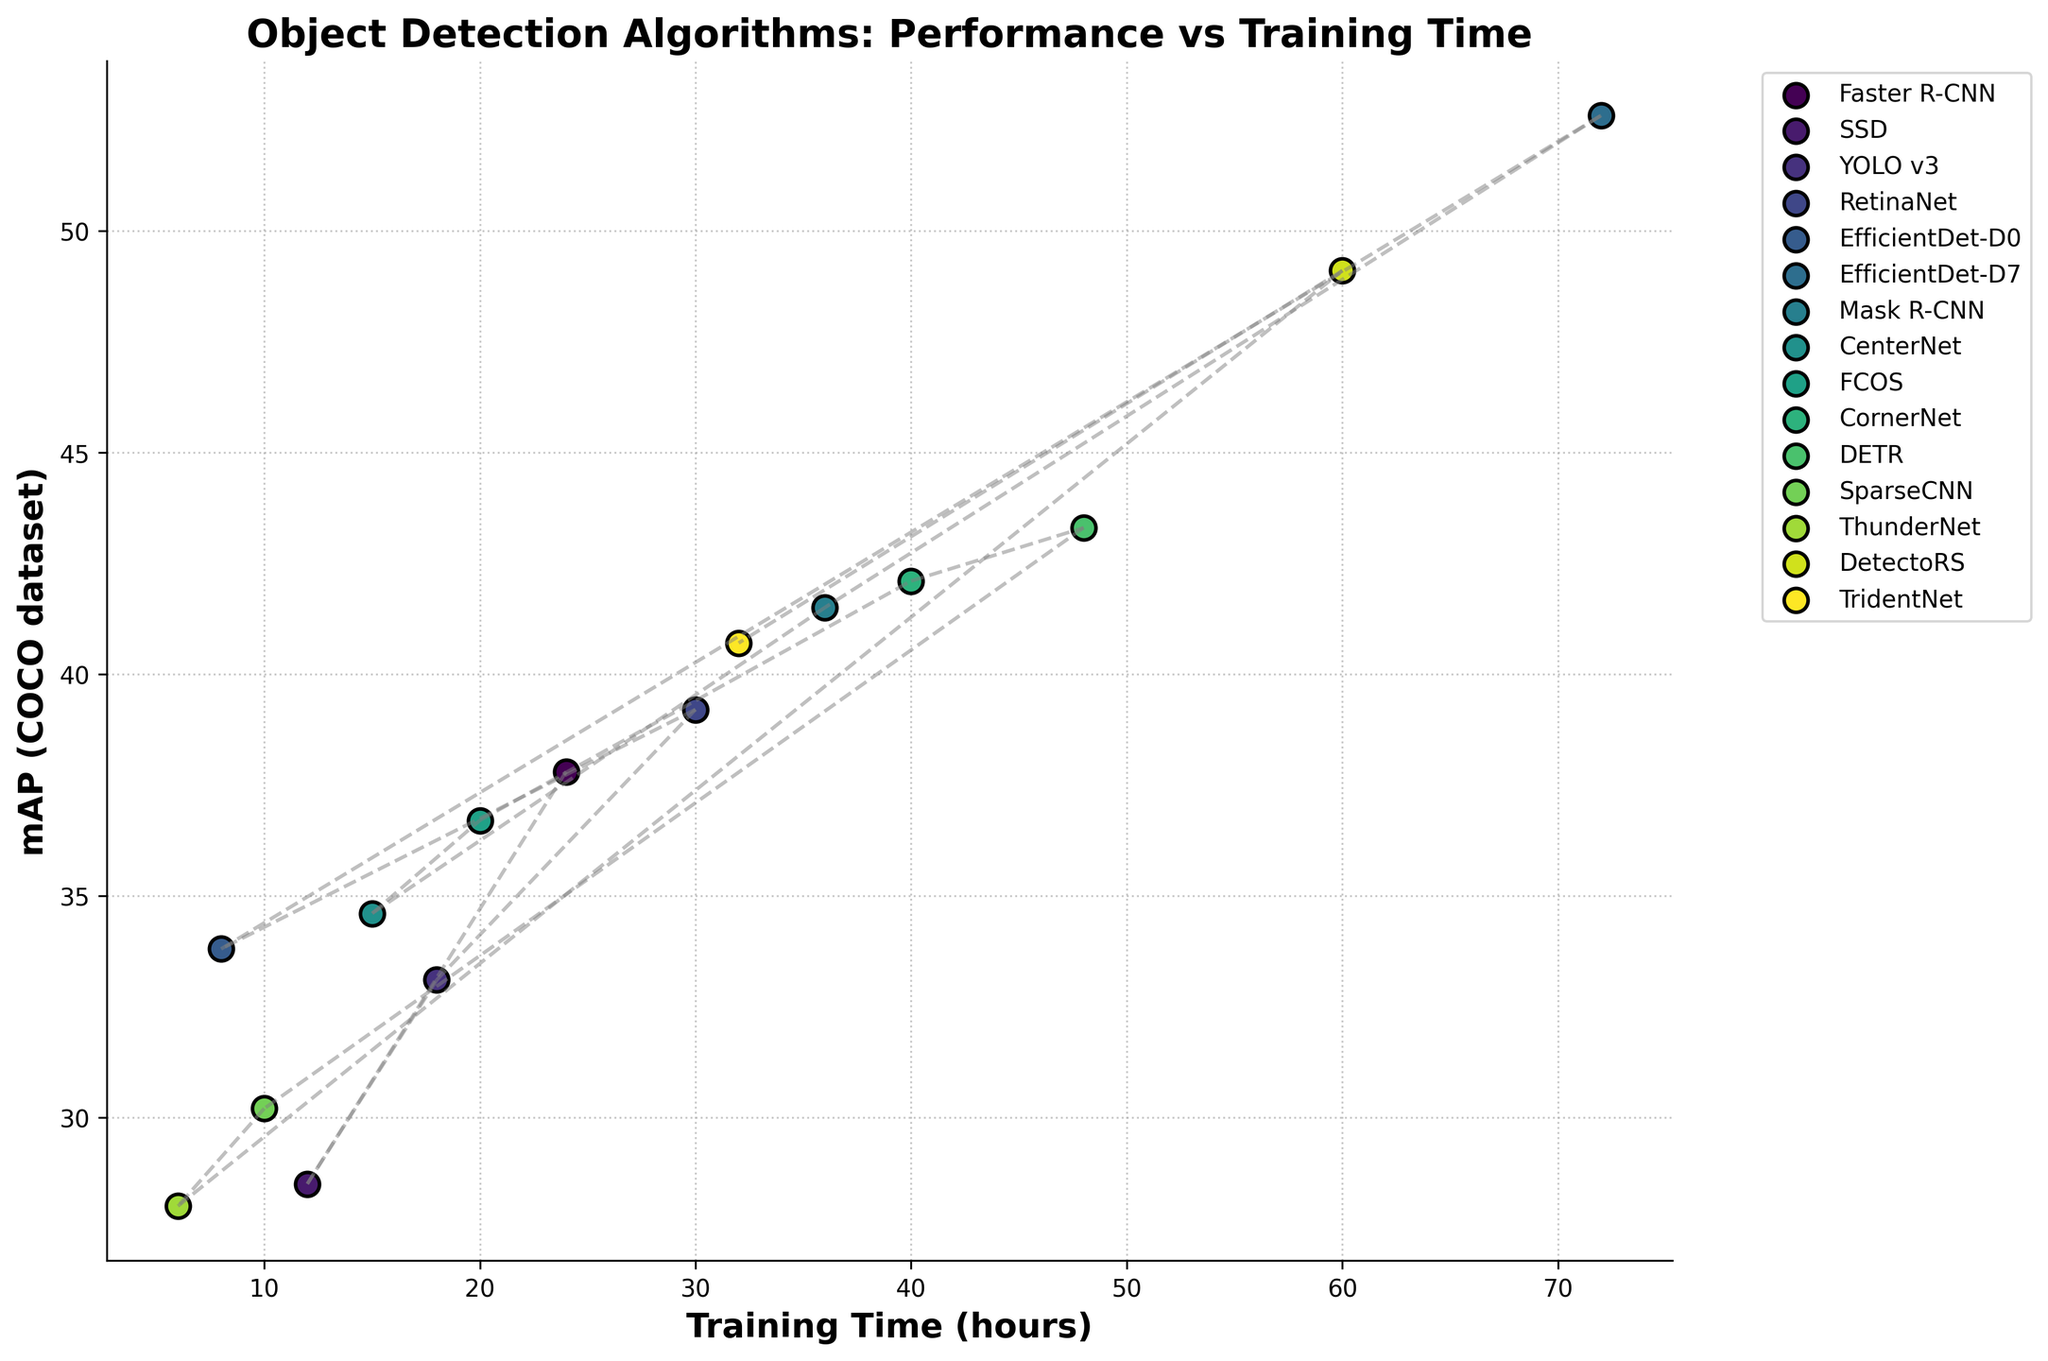Which model has the highest mAP on the COCO dataset? From the scatter points, identify the model with the highest placement on the y-axis, representing the highest mAP value. The model placed highest on the y-axis is EfficientDet-D7, with an mAP of 52.6.
Answer: EfficientDet-D7 Which model has the shortest training time? Check the data points at the leftmost position on the x-axis, representing the minimum training time. ThunderNet is the leftmost point with a training time of 6 hours.
Answer: ThunderNet Which model balances training time and performance (mAP) relatively well, considering both are within a moderate range? Look for a model that shows a reasonable training time and a decent mAP value. RetinaNet stands out with a training time of 30 hours and an mAP of 39.2, achieving a good balance.
Answer: RetinaNet What is the difference in training time between CornerNet and TridentNet? Identify the training times for CornerNet (40 hours) and TridentNet (32 hours), then calculate the difference. The difference is 40 - 32 = 8 hours.
Answer: 8 hours Among SSD, YOLO v3, and CenterNet, which has the highest mAP, and by how much? Find the mAP values for SSD (28.5), YOLO v3 (33.1), and CenterNet (34.6). CenterNet has the highest mAP. Calculate the differences: 34.6 - 33.1 = 1.5 and 34.6 - 28.5 = 6.1.
Answer: CenterNet, by 1.5 and 6.1 Comparing Faster R-CNN and Mask R-CNN, which has a better performance (mAP), and what is the corresponding increase in training time? Identify the mAP values and training times for the two models. Faster R-CNN has an mAP of 37.8 and a training time of 24 hours, while Mask R-CNN has an mAP of 41.5 and a training time of 36 hours. Mask R-CNN performs better, and the increase in training time is 36 - 24 = 12 hours.
Answer: Mask R-CNN, 12 hours What is the total training time for EfficientDet-D0 and EfficientDet-D7 combined? Sum up the training times for EfficientDet-D0 (8 hours) and EfficientDet-D7 (72 hours). The total is 8 + 72 = 80 hours.
Answer: 80 hours Which model has an mAP closest to 35, and what is its training time? Find the model with an mAP value nearest to 35. CenterNet has an mAP of 34.6, which is closest to 35. Its training time is 15 hours.
Answer: CenterNet, 15 hours Does a longer training time always correlate with a higher mAP? Analyze whether there is a clear pattern where a longer training time leads to a higher mAP. The EfficientDet-D7 with the highest mAP has the longest training time, but there are exceptions like CornerNet and DETR where mAP is high but training time is shorter than some other models. This indicates a general trend but not a strict correlation.
Answer: No 